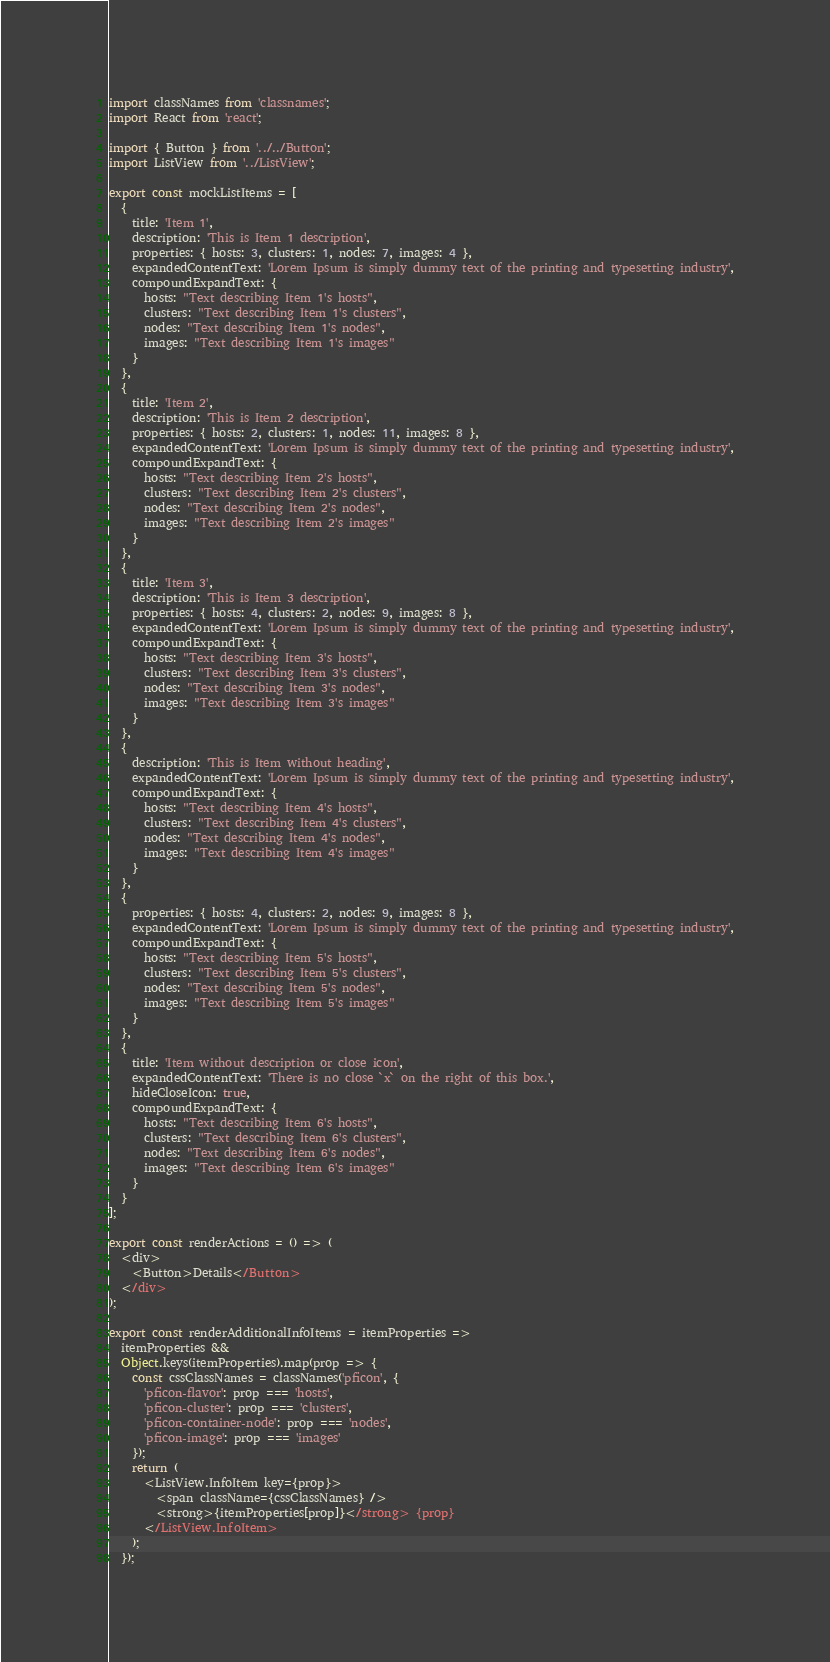Convert code to text. <code><loc_0><loc_0><loc_500><loc_500><_JavaScript_>import classNames from 'classnames';
import React from 'react';

import { Button } from '../../Button';
import ListView from '../ListView';

export const mockListItems = [
  {
    title: 'Item 1',
    description: 'This is Item 1 description',
    properties: { hosts: 3, clusters: 1, nodes: 7, images: 4 },
    expandedContentText: 'Lorem Ipsum is simply dummy text of the printing and typesetting industry',
    compoundExpandText: {
      hosts: "Text describing Item 1's hosts",
      clusters: "Text describing Item 1's clusters",
      nodes: "Text describing Item 1's nodes",
      images: "Text describing Item 1's images"
    }
  },
  {
    title: 'Item 2',
    description: 'This is Item 2 description',
    properties: { hosts: 2, clusters: 1, nodes: 11, images: 8 },
    expandedContentText: 'Lorem Ipsum is simply dummy text of the printing and typesetting industry',
    compoundExpandText: {
      hosts: "Text describing Item 2's hosts",
      clusters: "Text describing Item 2's clusters",
      nodes: "Text describing Item 2's nodes",
      images: "Text describing Item 2's images"
    }
  },
  {
    title: 'Item 3',
    description: 'This is Item 3 description',
    properties: { hosts: 4, clusters: 2, nodes: 9, images: 8 },
    expandedContentText: 'Lorem Ipsum is simply dummy text of the printing and typesetting industry',
    compoundExpandText: {
      hosts: "Text describing Item 3's hosts",
      clusters: "Text describing Item 3's clusters",
      nodes: "Text describing Item 3's nodes",
      images: "Text describing Item 3's images"
    }
  },
  {
    description: 'This is Item without heading',
    expandedContentText: 'Lorem Ipsum is simply dummy text of the printing and typesetting industry',
    compoundExpandText: {
      hosts: "Text describing Item 4's hosts",
      clusters: "Text describing Item 4's clusters",
      nodes: "Text describing Item 4's nodes",
      images: "Text describing Item 4's images"
    }
  },
  {
    properties: { hosts: 4, clusters: 2, nodes: 9, images: 8 },
    expandedContentText: 'Lorem Ipsum is simply dummy text of the printing and typesetting industry',
    compoundExpandText: {
      hosts: "Text describing Item 5's hosts",
      clusters: "Text describing Item 5's clusters",
      nodes: "Text describing Item 5's nodes",
      images: "Text describing Item 5's images"
    }
  },
  {
    title: 'Item without description or close icon',
    expandedContentText: 'There is no close `x` on the right of this box.',
    hideCloseIcon: true,
    compoundExpandText: {
      hosts: "Text describing Item 6's hosts",
      clusters: "Text describing Item 6's clusters",
      nodes: "Text describing Item 6's nodes",
      images: "Text describing Item 6's images"
    }
  }
];

export const renderActions = () => (
  <div>
    <Button>Details</Button>
  </div>
);

export const renderAdditionalInfoItems = itemProperties =>
  itemProperties &&
  Object.keys(itemProperties).map(prop => {
    const cssClassNames = classNames('pficon', {
      'pficon-flavor': prop === 'hosts',
      'pficon-cluster': prop === 'clusters',
      'pficon-container-node': prop === 'nodes',
      'pficon-image': prop === 'images'
    });
    return (
      <ListView.InfoItem key={prop}>
        <span className={cssClassNames} />
        <strong>{itemProperties[prop]}</strong> {prop}
      </ListView.InfoItem>
    );
  });
</code> 